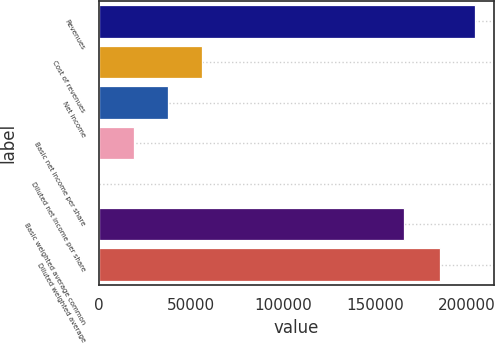Convert chart to OTSL. <chart><loc_0><loc_0><loc_500><loc_500><bar_chart><fcel>Revenues<fcel>Cost of revenues<fcel>Net income<fcel>Basic net income per share<fcel>Diluted net income per share<fcel>Basic weighted average common<fcel>Diluted weighted average<nl><fcel>204446<fcel>56105.8<fcel>37404<fcel>18702.1<fcel>0.2<fcel>165959<fcel>185744<nl></chart> 